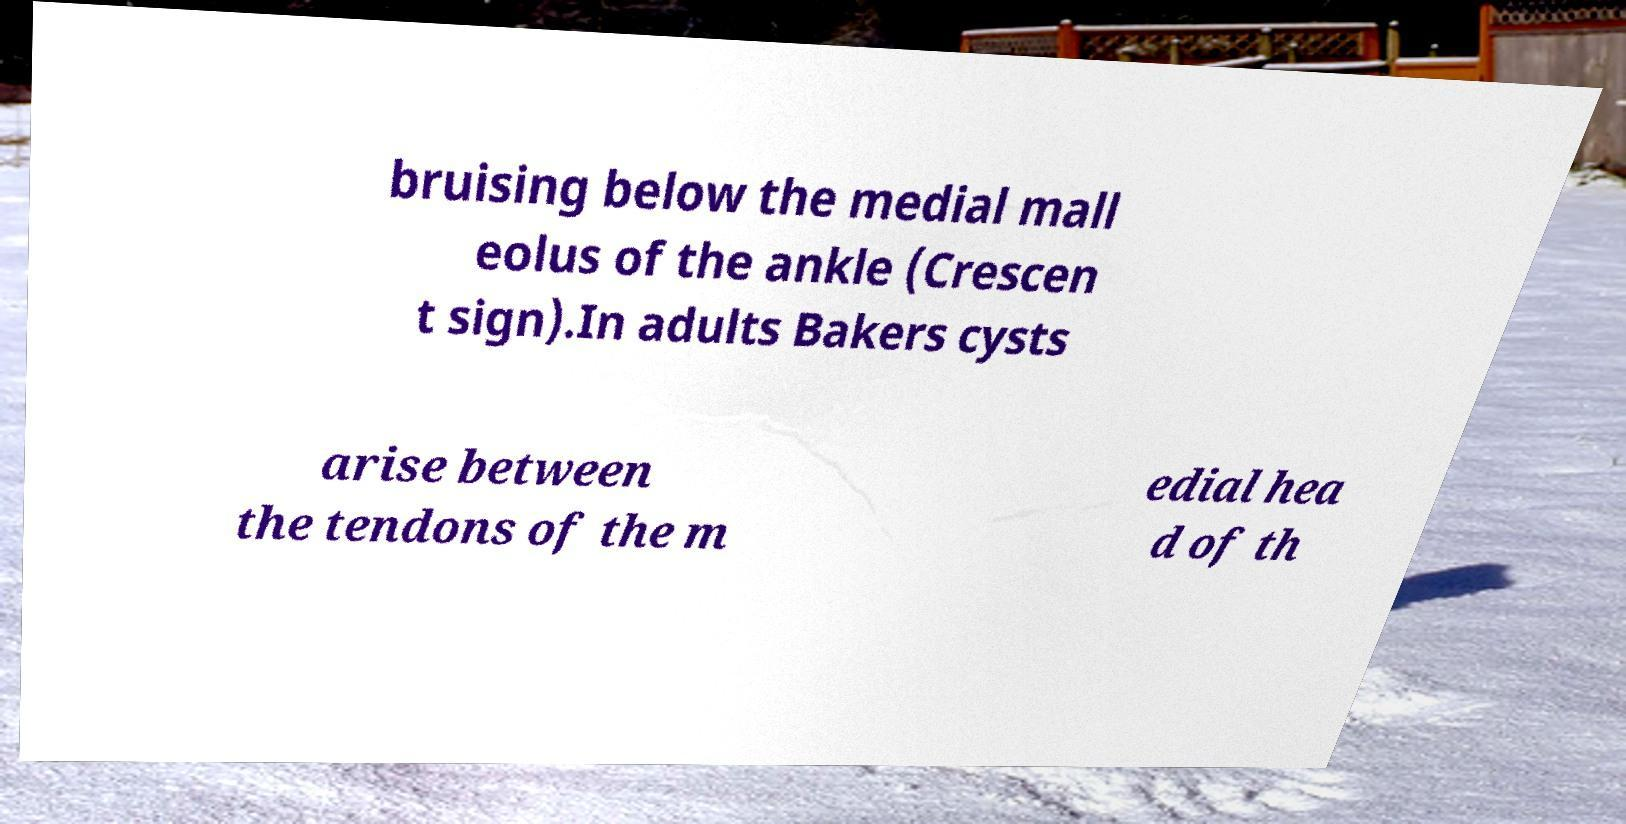Could you extract and type out the text from this image? bruising below the medial mall eolus of the ankle (Crescen t sign).In adults Bakers cysts arise between the tendons of the m edial hea d of th 